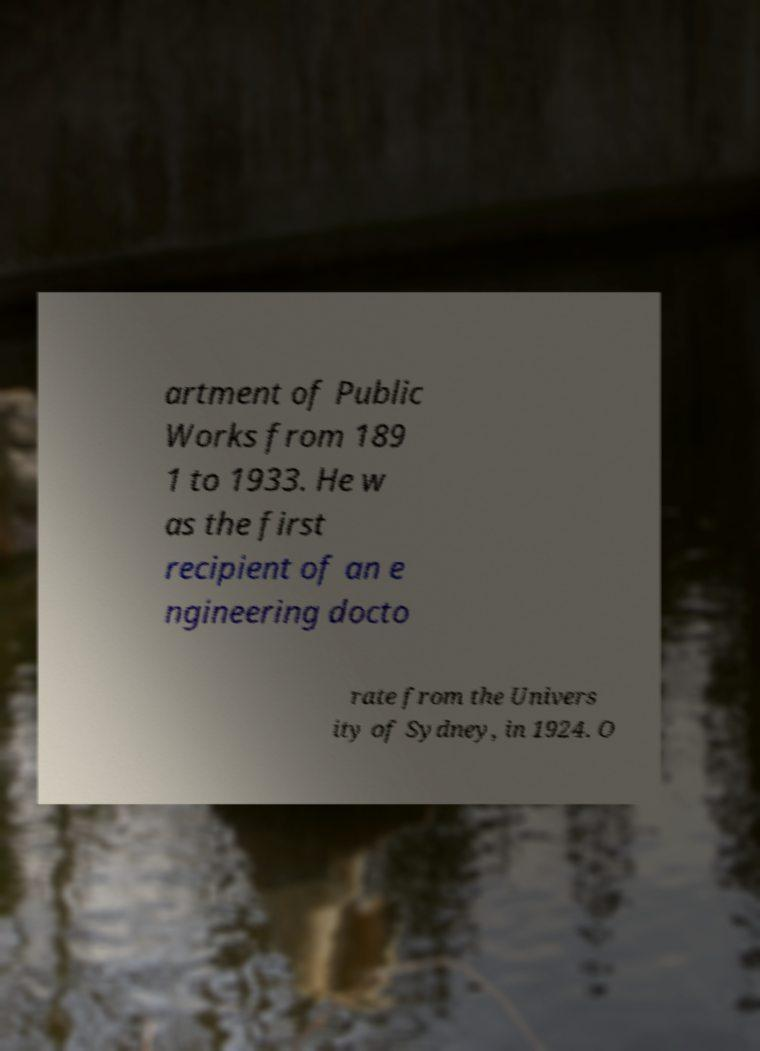There's text embedded in this image that I need extracted. Can you transcribe it verbatim? artment of Public Works from 189 1 to 1933. He w as the first recipient of an e ngineering docto rate from the Univers ity of Sydney, in 1924. O 